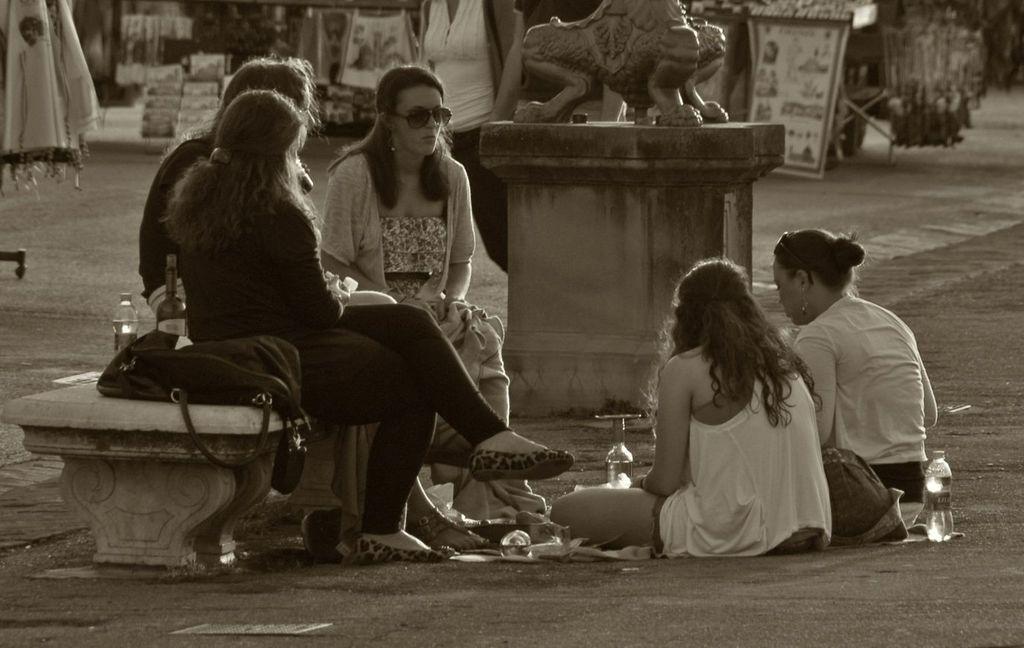In one or two sentences, can you explain what this image depicts? In this picture we can see a group of people where some are sitting on a bench and some are sitting on the ground, bottles, bag, stature and in the background we can see some objects. 